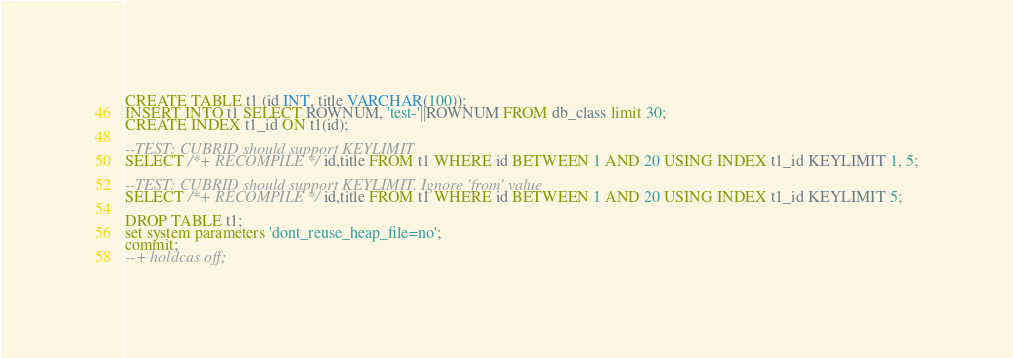<code> <loc_0><loc_0><loc_500><loc_500><_SQL_>CREATE TABLE t1 (id INT, title VARCHAR(100));
INSERT INTO t1 SELECT ROWNUM, 'test-'||ROWNUM FROM db_class limit 30;
CREATE INDEX t1_id ON t1(id);

--TEST: CUBRID should support KEYLIMIT
SELECT /*+ RECOMPILE */ id,title FROM t1 WHERE id BETWEEN 1 AND 20 USING INDEX t1_id KEYLIMIT 1, 5;

--TEST: CUBRID should support KEYLIMIT. Ignore 'from' value
SELECT /*+ RECOMPILE */ id,title FROM t1 WHERE id BETWEEN 1 AND 20 USING INDEX t1_id KEYLIMIT 5;

DROP TABLE t1;
set system parameters 'dont_reuse_heap_file=no';
commit;
--+ holdcas off;
</code> 